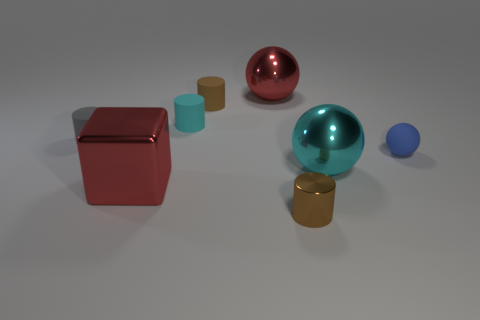Subtract all small cyan cylinders. How many cylinders are left? 3 Add 1 small cyan matte things. How many objects exist? 9 Subtract all cubes. How many objects are left? 7 Subtract 1 blocks. How many blocks are left? 0 Subtract all brown cylinders. How many cylinders are left? 2 Subtract all brown balls. How many cyan cylinders are left? 1 Subtract 2 brown cylinders. How many objects are left? 6 Subtract all red balls. Subtract all gray cylinders. How many balls are left? 2 Subtract all big metal blocks. Subtract all tiny brown things. How many objects are left? 5 Add 8 gray cylinders. How many gray cylinders are left? 9 